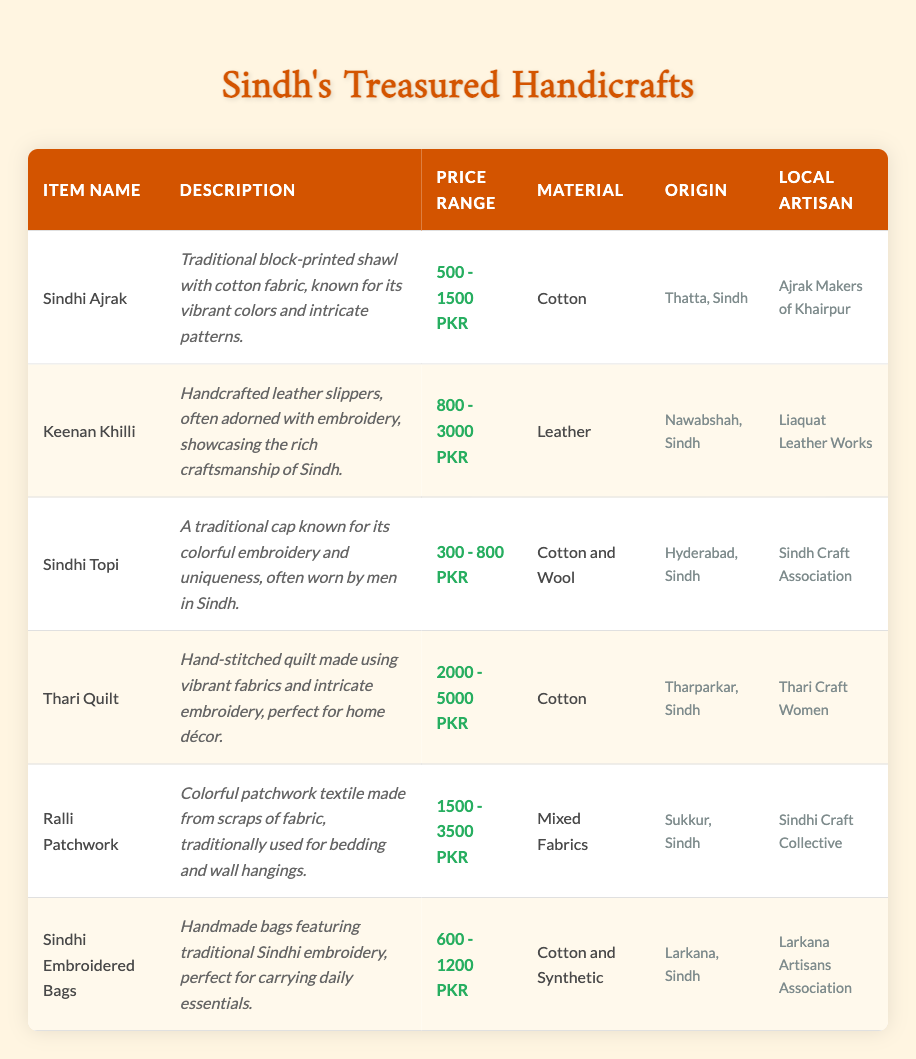What is the price range for the Sindhi Ajrak? The table lists the price range for Sindhi Ajrak as 500 - 1500 PKR, which is found in the "Price Range" column for that item.
Answer: 500 - 1500 PKR What material is used in the Keenan Khilli? According to the table, the material used in the Keenan Khilli is Leather, as specified in the "Material" column.
Answer: Leather Is the Sindhi Topi made from only cotton? The table states that the Sindhi Topi is made from Cotton and Wool, which indicates that it is not made from only cotton.
Answer: No What is the average price range of the Thari Quilt and Ralli Patchwork? The price range for the Thari Quilt is 2000 - 5000 PKR and for Ralli Patchwork is 1500 - 3500 PKR. To calculate the average, take the average of the lower and upper limits: (2000 + 1500) / 2 = 1750 and (5000 + 3500) / 2 = 4250. Therefore, the average is 1750 - 4250 PKR.
Answer: 1750 - 4250 PKR Which item has the highest price range? Comparing the price ranges, the Thari Quilt has a price range of 2000 - 5000 PKR, which is higher than the others listed. Therefore, it has the highest price range among all items in the table.
Answer: Thari Quilt How many local artisans are associated with the items listed? The table mentions six different local artisans for each item listed. Each artisan corresponds to one item, so simply counting them results in six unique artisans associated with the items.
Answer: 6 Are the Sindhi Embroidered Bags suitable for carrying daily essentials? Yes, the description for Sindhi Embroidered Bags explicitly states that they are perfect for carrying daily essentials, confirming that they are indeed suitable for that purpose.
Answer: Yes What was the origin of the item with the least expensive price range? The item with the least expensive price range is the Sindhi Topi, which has a price range of 300 - 800 PKR. Its origin, as noted in the table, is Hyderabad, Sindh.
Answer: Hyderabad, Sindh List the items that use Cotton as their main material. The items using Cotton as their main material include Sindhi Ajrak, Sindhi Topi, Thari Quilt, and Sindhi Embroidered Bags. These items are identified in the "Material" column where Cotton is specifically mentioned.
Answer: Sindhi Ajrak, Sindhi Topi, Thari Quilt, Sindhi Embroidered Bags 